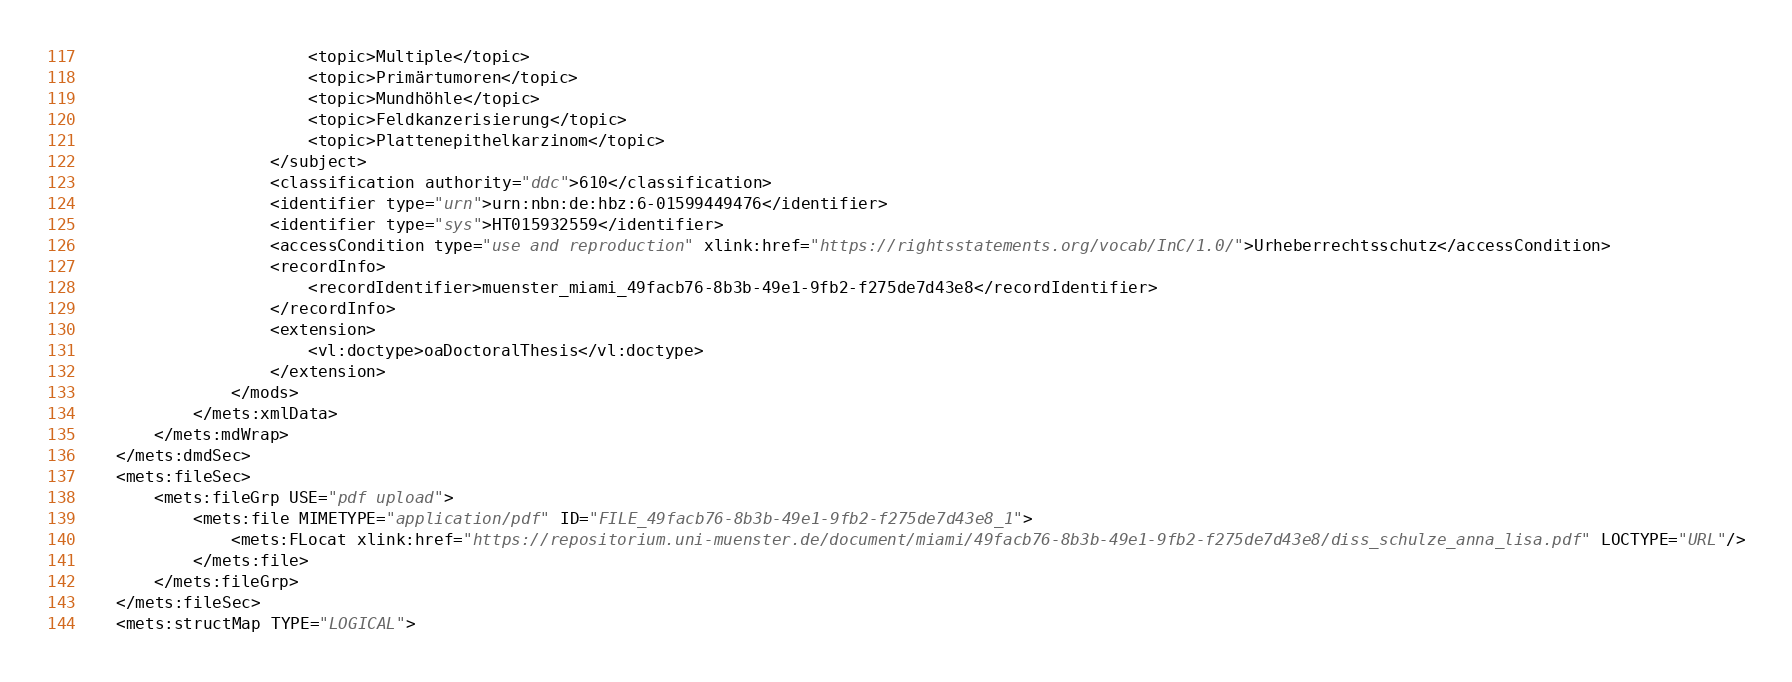Convert code to text. <code><loc_0><loc_0><loc_500><loc_500><_XML_>                        <topic>Multiple</topic>
                        <topic>Primärtumoren</topic>
                        <topic>Mundhöhle</topic>
                        <topic>Feldkanzerisierung</topic>
                        <topic>Plattenepithelkarzinom</topic>
                    </subject>
                    <classification authority="ddc">610</classification>
                    <identifier type="urn">urn:nbn:de:hbz:6-01599449476</identifier>
                    <identifier type="sys">HT015932559</identifier>
                    <accessCondition type="use and reproduction" xlink:href="https://rightsstatements.org/vocab/InC/1.0/">Urheberrechtsschutz</accessCondition>
                    <recordInfo>
                        <recordIdentifier>muenster_miami_49facb76-8b3b-49e1-9fb2-f275de7d43e8</recordIdentifier>
                    </recordInfo>
                    <extension>
                        <vl:doctype>oaDoctoralThesis</vl:doctype>
                    </extension>
                </mods>
            </mets:xmlData>
        </mets:mdWrap>
    </mets:dmdSec>
    <mets:fileSec>
        <mets:fileGrp USE="pdf upload">
            <mets:file MIMETYPE="application/pdf" ID="FILE_49facb76-8b3b-49e1-9fb2-f275de7d43e8_1">
                <mets:FLocat xlink:href="https://repositorium.uni-muenster.de/document/miami/49facb76-8b3b-49e1-9fb2-f275de7d43e8/diss_schulze_anna_lisa.pdf" LOCTYPE="URL"/>
            </mets:file>
        </mets:fileGrp>
    </mets:fileSec>
    <mets:structMap TYPE="LOGICAL"></code> 